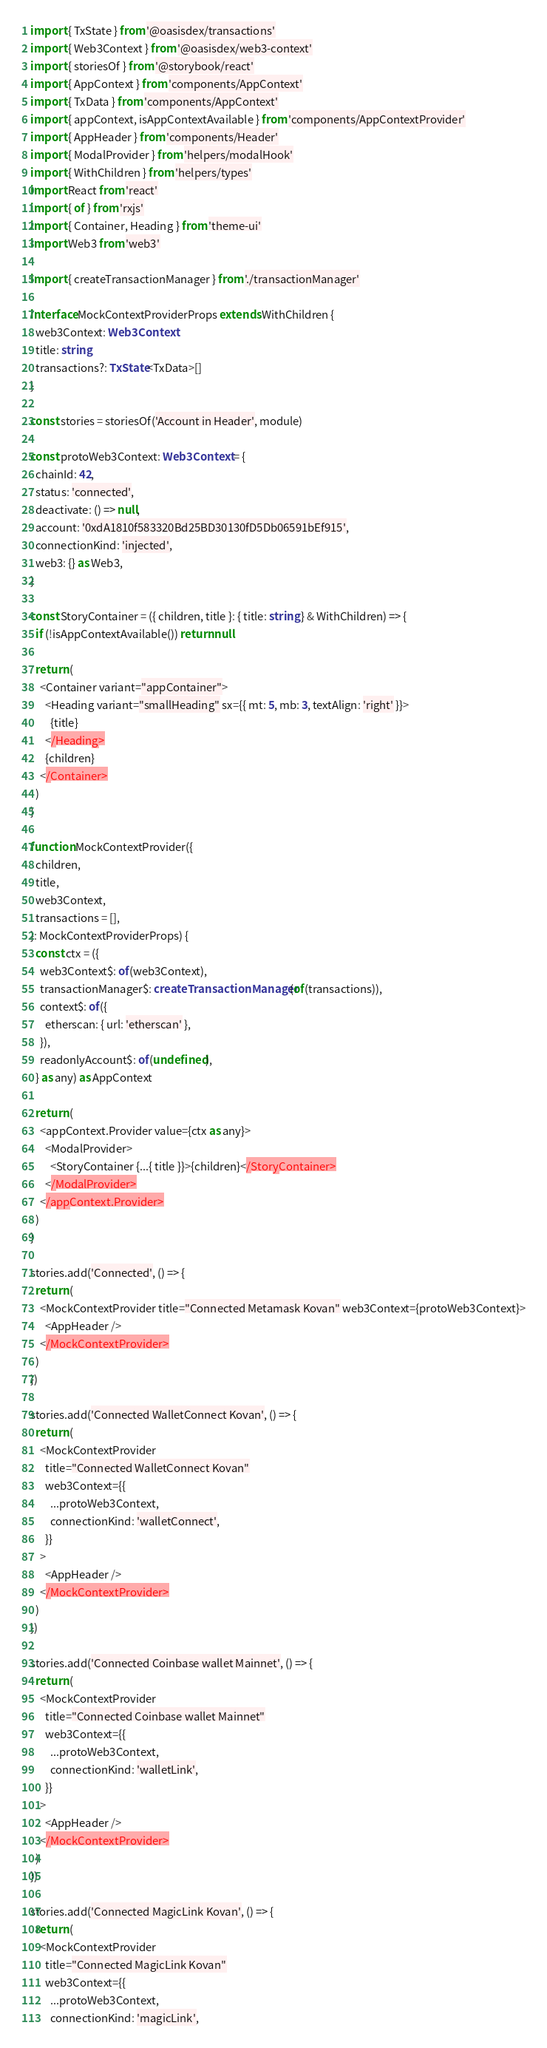Convert code to text. <code><loc_0><loc_0><loc_500><loc_500><_TypeScript_>import { TxState } from '@oasisdex/transactions'
import { Web3Context } from '@oasisdex/web3-context'
import { storiesOf } from '@storybook/react'
import { AppContext } from 'components/AppContext'
import { TxData } from 'components/AppContext'
import { appContext, isAppContextAvailable } from 'components/AppContextProvider'
import { AppHeader } from 'components/Header'
import { ModalProvider } from 'helpers/modalHook'
import { WithChildren } from 'helpers/types'
import React from 'react'
import { of } from 'rxjs'
import { Container, Heading } from 'theme-ui'
import Web3 from 'web3'

import { createTransactionManager } from './transactionManager'

interface MockContextProviderProps extends WithChildren {
  web3Context: Web3Context
  title: string
  transactions?: TxState<TxData>[]
}

const stories = storiesOf('Account in Header', module)

const protoWeb3Context: Web3Context = {
  chainId: 42,
  status: 'connected',
  deactivate: () => null,
  account: '0xdA1810f583320Bd25BD30130fD5Db06591bEf915',
  connectionKind: 'injected',
  web3: {} as Web3,
}

const StoryContainer = ({ children, title }: { title: string } & WithChildren) => {
  if (!isAppContextAvailable()) return null

  return (
    <Container variant="appContainer">
      <Heading variant="smallHeading" sx={{ mt: 5, mb: 3, textAlign: 'right' }}>
        {title}
      </Heading>
      {children}
    </Container>
  )
}

function MockContextProvider({
  children,
  title,
  web3Context,
  transactions = [],
}: MockContextProviderProps) {
  const ctx = ({
    web3Context$: of(web3Context),
    transactionManager$: createTransactionManager(of(transactions)),
    context$: of({
      etherscan: { url: 'etherscan' },
    }),
    readonlyAccount$: of(undefined),
  } as any) as AppContext

  return (
    <appContext.Provider value={ctx as any}>
      <ModalProvider>
        <StoryContainer {...{ title }}>{children}</StoryContainer>
      </ModalProvider>
    </appContext.Provider>
  )
}

stories.add('Connected', () => {
  return (
    <MockContextProvider title="Connected Metamask Kovan" web3Context={protoWeb3Context}>
      <AppHeader />
    </MockContextProvider>
  )
})

stories.add('Connected WalletConnect Kovan', () => {
  return (
    <MockContextProvider
      title="Connected WalletConnect Kovan"
      web3Context={{
        ...protoWeb3Context,
        connectionKind: 'walletConnect',
      }}
    >
      <AppHeader />
    </MockContextProvider>
  )
})

stories.add('Connected Coinbase wallet Mainnet', () => {
  return (
    <MockContextProvider
      title="Connected Coinbase wallet Mainnet"
      web3Context={{
        ...protoWeb3Context,
        connectionKind: 'walletLink',
      }}
    >
      <AppHeader />
    </MockContextProvider>
  )
})

stories.add('Connected MagicLink Kovan', () => {
  return (
    <MockContextProvider
      title="Connected MagicLink Kovan"
      web3Context={{
        ...protoWeb3Context,
        connectionKind: 'magicLink',</code> 